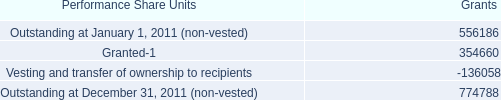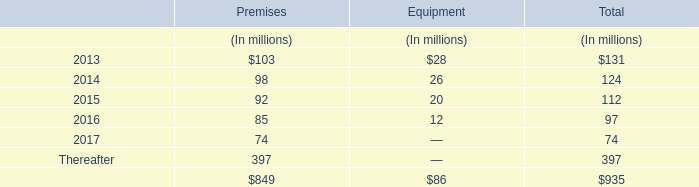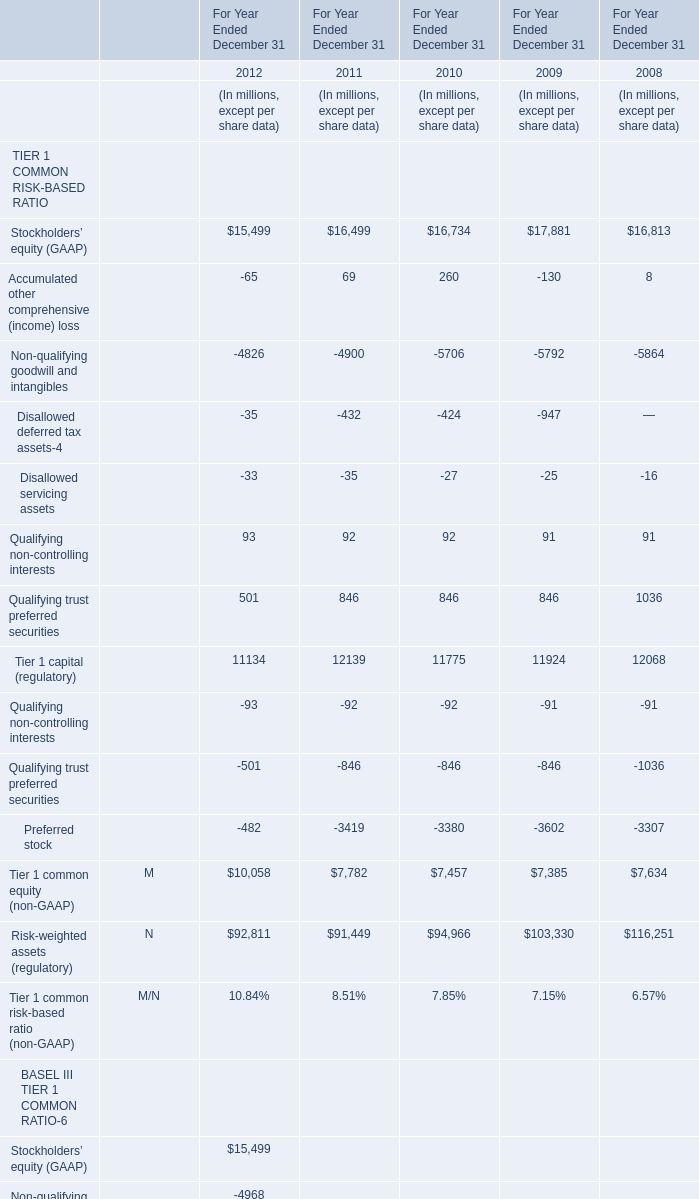What was the total amount of Stockholders’ equity (GAAP) greater than 13000 in 2008? (in million) 
Computations: (16813 + 116251)
Answer: 133064.0. 